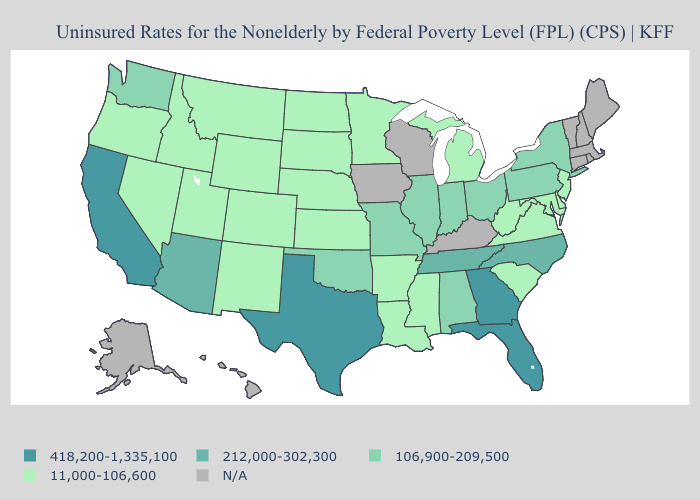Which states have the highest value in the USA?
Short answer required. California, Florida, Georgia, Texas. What is the value of Wisconsin?
Be succinct. N/A. Does the map have missing data?
Quick response, please. Yes. Is the legend a continuous bar?
Short answer required. No. What is the value of North Dakota?
Write a very short answer. 11,000-106,600. Does the first symbol in the legend represent the smallest category?
Be succinct. No. What is the value of Wisconsin?
Give a very brief answer. N/A. Name the states that have a value in the range 11,000-106,600?
Keep it brief. Arkansas, Colorado, Delaware, Idaho, Kansas, Louisiana, Maryland, Michigan, Minnesota, Mississippi, Montana, Nebraska, Nevada, New Jersey, New Mexico, North Dakota, Oregon, South Carolina, South Dakota, Utah, Virginia, West Virginia, Wyoming. Name the states that have a value in the range 212,000-302,300?
Keep it brief. Arizona, North Carolina, Tennessee. What is the value of Missouri?
Keep it brief. 106,900-209,500. What is the value of Maine?
Short answer required. N/A. Among the states that border Arizona , does California have the highest value?
Quick response, please. Yes. Name the states that have a value in the range 418,200-1,335,100?
Be succinct. California, Florida, Georgia, Texas. 